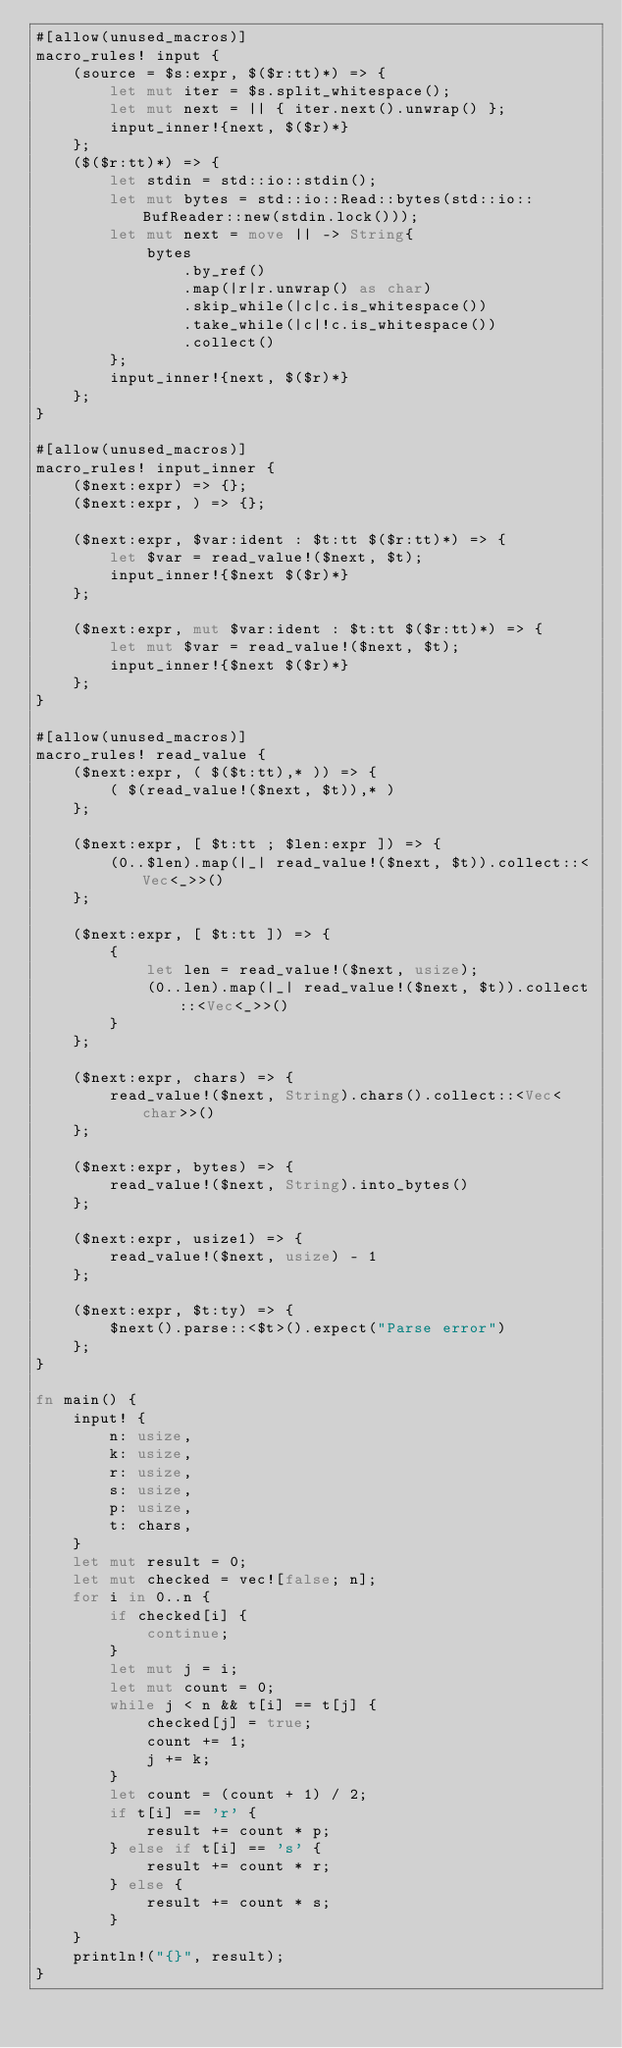<code> <loc_0><loc_0><loc_500><loc_500><_Rust_>#[allow(unused_macros)]
macro_rules! input {
    (source = $s:expr, $($r:tt)*) => {
        let mut iter = $s.split_whitespace();
        let mut next = || { iter.next().unwrap() };
        input_inner!{next, $($r)*}
    };
    ($($r:tt)*) => {
        let stdin = std::io::stdin();
        let mut bytes = std::io::Read::bytes(std::io::BufReader::new(stdin.lock()));
        let mut next = move || -> String{
            bytes
                .by_ref()
                .map(|r|r.unwrap() as char)
                .skip_while(|c|c.is_whitespace())
                .take_while(|c|!c.is_whitespace())
                .collect()
        };
        input_inner!{next, $($r)*}
    };
}

#[allow(unused_macros)]
macro_rules! input_inner {
    ($next:expr) => {};
    ($next:expr, ) => {};

    ($next:expr, $var:ident : $t:tt $($r:tt)*) => {
        let $var = read_value!($next, $t);
        input_inner!{$next $($r)*}
    };

    ($next:expr, mut $var:ident : $t:tt $($r:tt)*) => {
        let mut $var = read_value!($next, $t);
        input_inner!{$next $($r)*}
    };
}

#[allow(unused_macros)]
macro_rules! read_value {
    ($next:expr, ( $($t:tt),* )) => {
        ( $(read_value!($next, $t)),* )
    };

    ($next:expr, [ $t:tt ; $len:expr ]) => {
        (0..$len).map(|_| read_value!($next, $t)).collect::<Vec<_>>()
    };

    ($next:expr, [ $t:tt ]) => {
        {
            let len = read_value!($next, usize);
            (0..len).map(|_| read_value!($next, $t)).collect::<Vec<_>>()
        }
    };

    ($next:expr, chars) => {
        read_value!($next, String).chars().collect::<Vec<char>>()
    };

    ($next:expr, bytes) => {
        read_value!($next, String).into_bytes()
    };

    ($next:expr, usize1) => {
        read_value!($next, usize) - 1
    };

    ($next:expr, $t:ty) => {
        $next().parse::<$t>().expect("Parse error")
    };
}

fn main() {
    input! {
        n: usize,
        k: usize,
        r: usize,
        s: usize,
        p: usize,
        t: chars,
    }
    let mut result = 0;
    let mut checked = vec![false; n];
    for i in 0..n {
        if checked[i] {
            continue;
        }
        let mut j = i;
        let mut count = 0;
        while j < n && t[i] == t[j] {
            checked[j] = true;
            count += 1;
            j += k;
        }
        let count = (count + 1) / 2;
        if t[i] == 'r' {
            result += count * p;
        } else if t[i] == 's' {
            result += count * r;
        } else {
            result += count * s;
        }
    }
    println!("{}", result);
}
</code> 